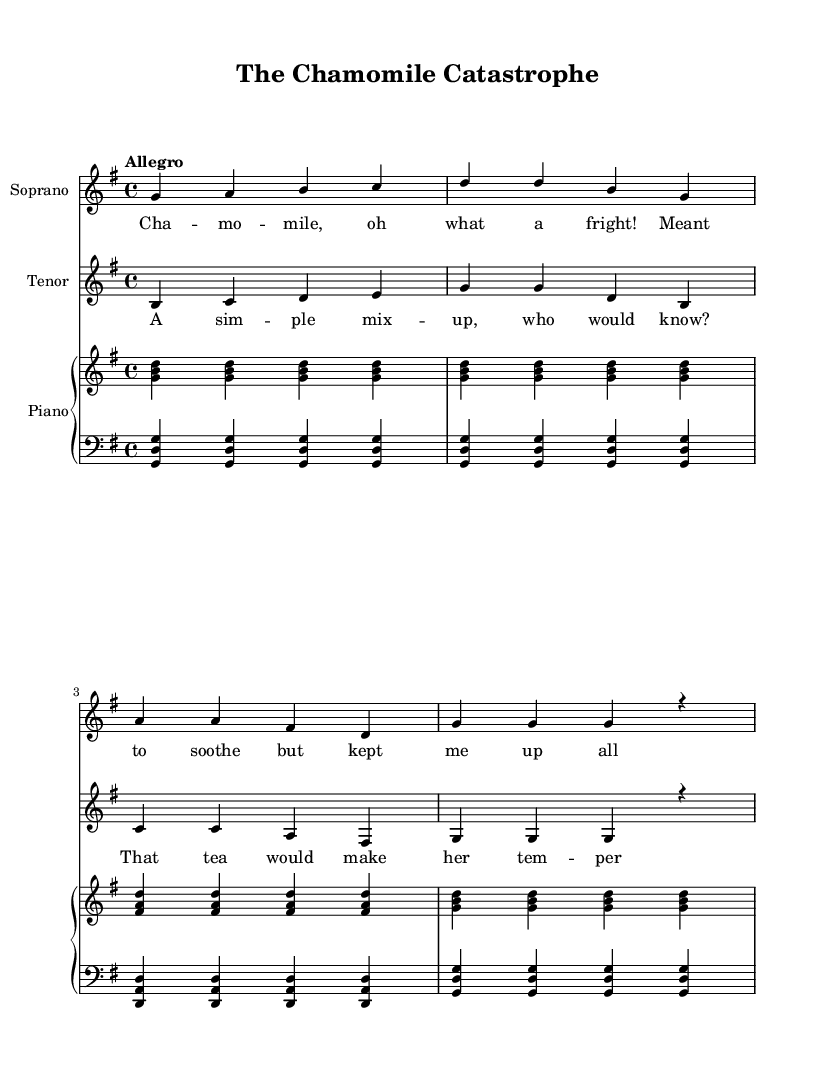What is the key signature of this music? The key signature is G major, which has one sharp (F#) and is indicated at the beginning of the staff.
Answer: G major What is the time signature of this piece? The time signature is 4/4, which means there are four beats in each measure, indicated at the beginning of the score.
Answer: 4/4 What is the tempo marking of this piece? The tempo marking is "Allegro," which suggests a lively and fast tempo. This is usually written above the staff near the beginning of the score.
Answer: Allegro How many measures are in the soprano part? The soprano part consists of four measures, as counted by the vertical lines that separate them on the staff.
Answer: Four measures What is the primary theme of the lyrics in this opera? The primary theme of the lyrics revolves around a misunderstanding involving chamomile, which is humorously described in the text. This is derived from the content of the lyrics provided.
Answer: Misunderstanding about chamomile What instruments accompany the vocal parts in this opera? The instruments accompanying the vocal parts are a piano, indicated by the presence of both right-hand (RH) and left-hand (LH) staves.
Answer: Piano What mood does the music convey overall? The mood of the music conveys a lighthearted and comedic feel, indicated by the playful tempo and the humorous nature of the lyrics and context.
Answer: Lighthearted 